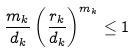Convert formula to latex. <formula><loc_0><loc_0><loc_500><loc_500>\frac { m _ { k } } { d _ { k } } \left ( \frac { r _ { k } } { d _ { k } } \right ) ^ { m _ { k } } \leq 1</formula> 